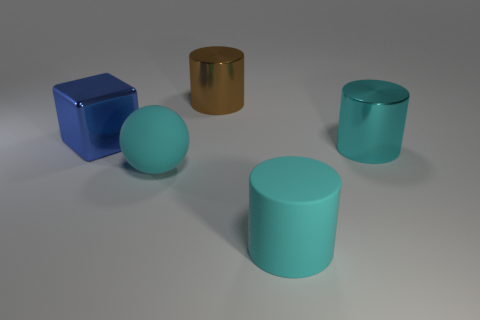Are there the same number of blue metal blocks that are in front of the cyan matte sphere and cyan matte spheres?
Make the answer very short. No. How many other things are the same color as the matte cylinder?
Provide a succinct answer. 2. Is the number of big blue blocks that are in front of the matte cylinder less than the number of tiny gray rubber objects?
Offer a terse response. No. Are there any cyan objects that have the same size as the brown object?
Provide a short and direct response. Yes. There is a large matte sphere; does it have the same color as the metallic cylinder that is behind the large cube?
Your answer should be compact. No. There is a large metal thing that is behind the big blue shiny block; what number of big shiny cylinders are to the right of it?
Provide a short and direct response. 1. There is a large metal cylinder that is left of the big metallic cylinder that is in front of the large blue metallic object; what is its color?
Ensure brevity in your answer.  Brown. The cylinder that is in front of the block and behind the cyan rubber cylinder is made of what material?
Your answer should be very brief. Metal. Are there any other blue objects that have the same shape as the blue shiny thing?
Provide a short and direct response. No. Does the metallic thing behind the block have the same shape as the big blue shiny thing?
Keep it short and to the point. No. 